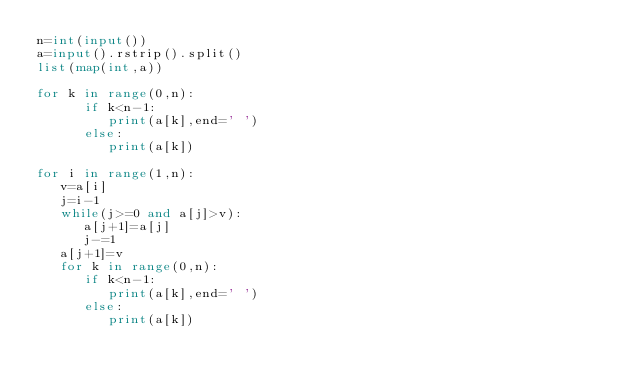Convert code to text. <code><loc_0><loc_0><loc_500><loc_500><_Python_>n=int(input())
a=input().rstrip().split()
list(map(int,a))

for k in range(0,n):
      if k<n-1:
         print(a[k],end=' ')
      else:
         print(a[k])

for i in range(1,n):
   v=a[i]
   j=i-1
   while(j>=0 and a[j]>v):
      a[j+1]=a[j]
      j-=1
   a[j+1]=v
   for k in range(0,n):
      if k<n-1:
         print(a[k],end=' ')
      else:
         print(a[k])
</code> 